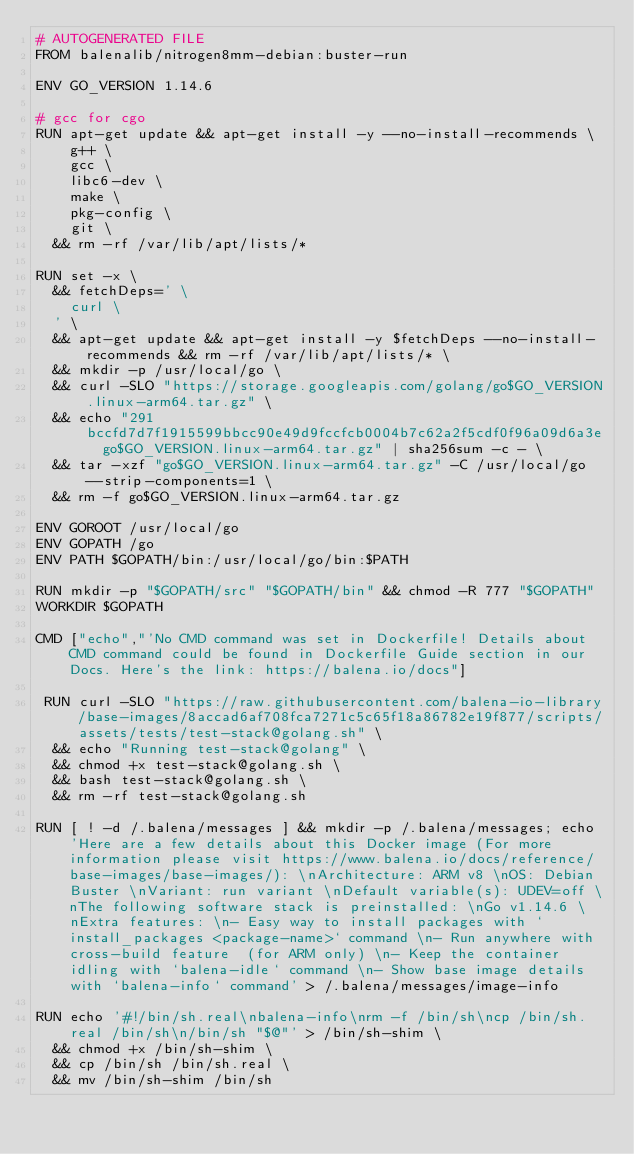Convert code to text. <code><loc_0><loc_0><loc_500><loc_500><_Dockerfile_># AUTOGENERATED FILE
FROM balenalib/nitrogen8mm-debian:buster-run

ENV GO_VERSION 1.14.6

# gcc for cgo
RUN apt-get update && apt-get install -y --no-install-recommends \
		g++ \
		gcc \
		libc6-dev \
		make \
		pkg-config \
		git \
	&& rm -rf /var/lib/apt/lists/*

RUN set -x \
	&& fetchDeps=' \
		curl \
	' \
	&& apt-get update && apt-get install -y $fetchDeps --no-install-recommends && rm -rf /var/lib/apt/lists/* \
	&& mkdir -p /usr/local/go \
	&& curl -SLO "https://storage.googleapis.com/golang/go$GO_VERSION.linux-arm64.tar.gz" \
	&& echo "291bccfd7d7f1915599bbcc90e49d9fccfcb0004b7c62a2f5cdf0f96a09d6a3e  go$GO_VERSION.linux-arm64.tar.gz" | sha256sum -c - \
	&& tar -xzf "go$GO_VERSION.linux-arm64.tar.gz" -C /usr/local/go --strip-components=1 \
	&& rm -f go$GO_VERSION.linux-arm64.tar.gz

ENV GOROOT /usr/local/go
ENV GOPATH /go
ENV PATH $GOPATH/bin:/usr/local/go/bin:$PATH

RUN mkdir -p "$GOPATH/src" "$GOPATH/bin" && chmod -R 777 "$GOPATH"
WORKDIR $GOPATH

CMD ["echo","'No CMD command was set in Dockerfile! Details about CMD command could be found in Dockerfile Guide section in our Docs. Here's the link: https://balena.io/docs"]

 RUN curl -SLO "https://raw.githubusercontent.com/balena-io-library/base-images/8accad6af708fca7271c5c65f18a86782e19f877/scripts/assets/tests/test-stack@golang.sh" \
  && echo "Running test-stack@golang" \
  && chmod +x test-stack@golang.sh \
  && bash test-stack@golang.sh \
  && rm -rf test-stack@golang.sh 

RUN [ ! -d /.balena/messages ] && mkdir -p /.balena/messages; echo 'Here are a few details about this Docker image (For more information please visit https://www.balena.io/docs/reference/base-images/base-images/): \nArchitecture: ARM v8 \nOS: Debian Buster \nVariant: run variant \nDefault variable(s): UDEV=off \nThe following software stack is preinstalled: \nGo v1.14.6 \nExtra features: \n- Easy way to install packages with `install_packages <package-name>` command \n- Run anywhere with cross-build feature  (for ARM only) \n- Keep the container idling with `balena-idle` command \n- Show base image details with `balena-info` command' > /.balena/messages/image-info

RUN echo '#!/bin/sh.real\nbalena-info\nrm -f /bin/sh\ncp /bin/sh.real /bin/sh\n/bin/sh "$@"' > /bin/sh-shim \
	&& chmod +x /bin/sh-shim \
	&& cp /bin/sh /bin/sh.real \
	&& mv /bin/sh-shim /bin/sh</code> 